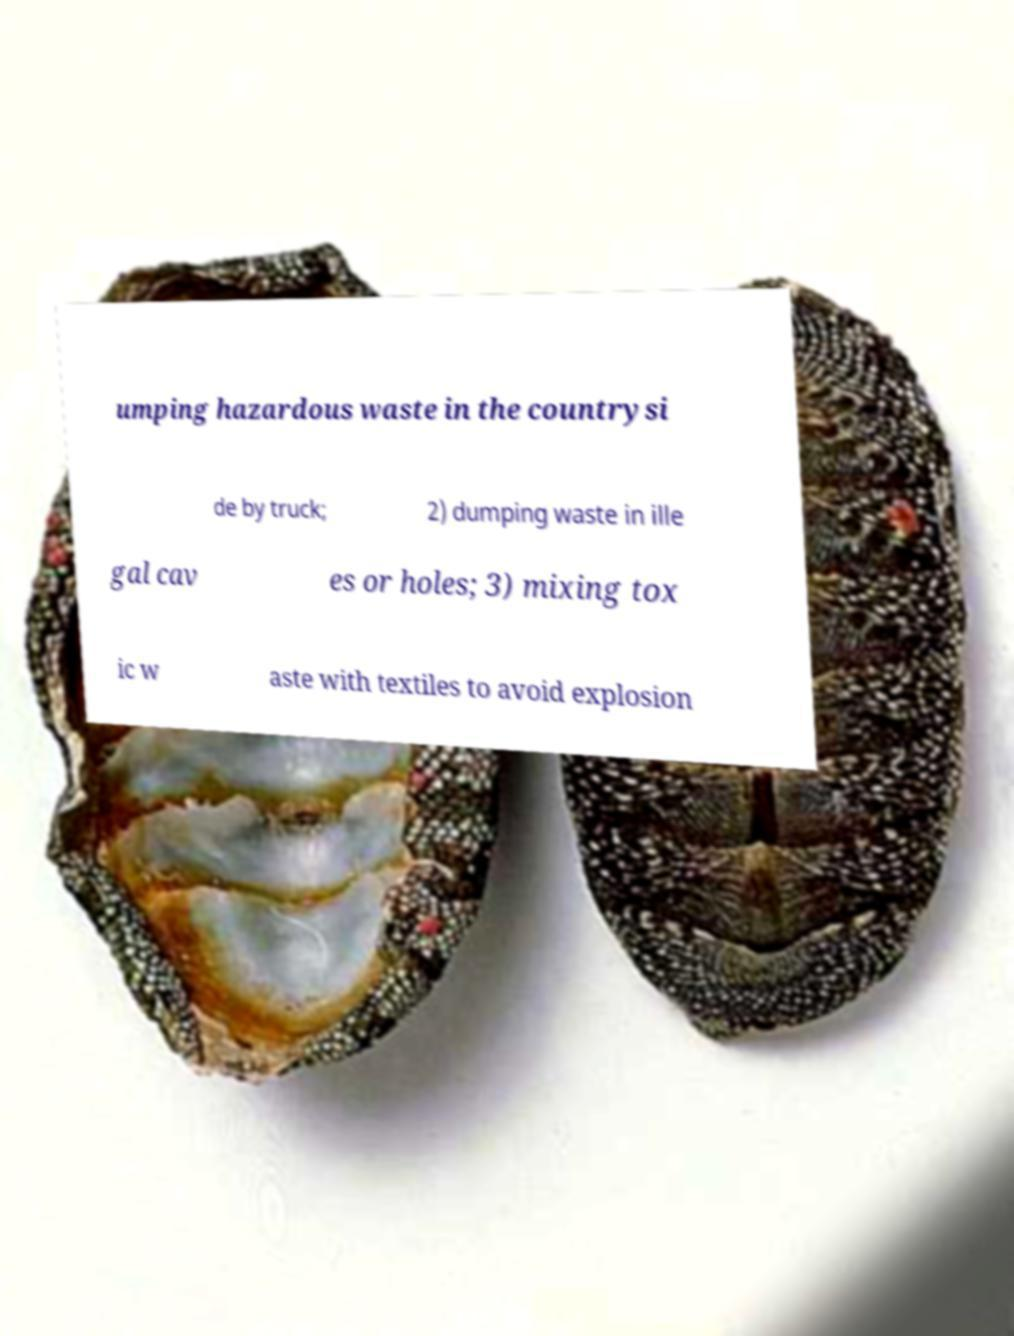Please identify and transcribe the text found in this image. umping hazardous waste in the countrysi de by truck; 2) dumping waste in ille gal cav es or holes; 3) mixing tox ic w aste with textiles to avoid explosion 